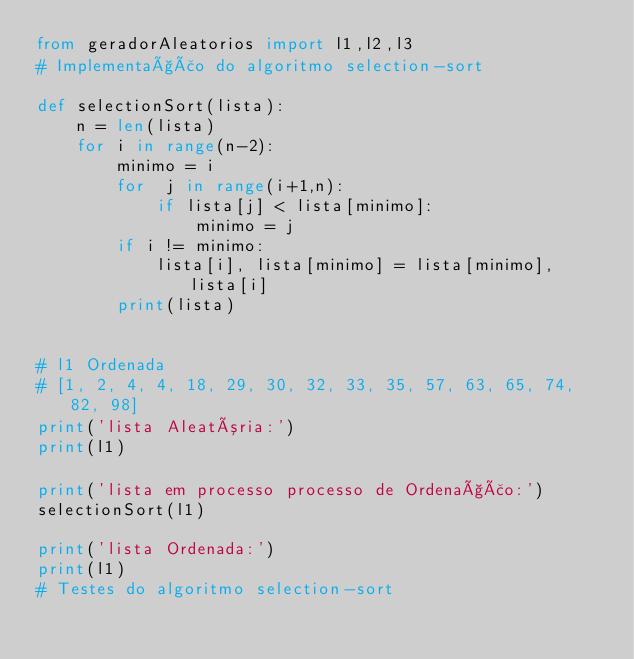<code> <loc_0><loc_0><loc_500><loc_500><_Python_>from geradorAleatorios import l1,l2,l3
# Implementação do algoritmo selection-sort

def selectionSort(lista):
    n = len(lista)
    for i in range(n-2):
        minimo = i
        for  j in range(i+1,n):
            if lista[j] < lista[minimo]:
                minimo = j
        if i != minimo:
            lista[i], lista[minimo] = lista[minimo], lista[i]
        print(lista)
            

# l1 Ordenada
# [1, 2, 4, 4, 18, 29, 30, 32, 33, 35, 57, 63, 65, 74, 82, 98]
print('lista Aleatória:')
print(l1)

print('lista em processo processo de Ordenação:')
selectionSort(l1)

print('lista Ordenada:')
print(l1)
# Testes do algoritmo selection-sort</code> 